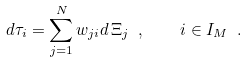Convert formula to latex. <formula><loc_0><loc_0><loc_500><loc_500>d \tau _ { i } = \sum _ { j = 1 } ^ { N } w _ { j i } d \, \Xi _ { j } \ , \quad i \in I _ { M } \ .</formula> 